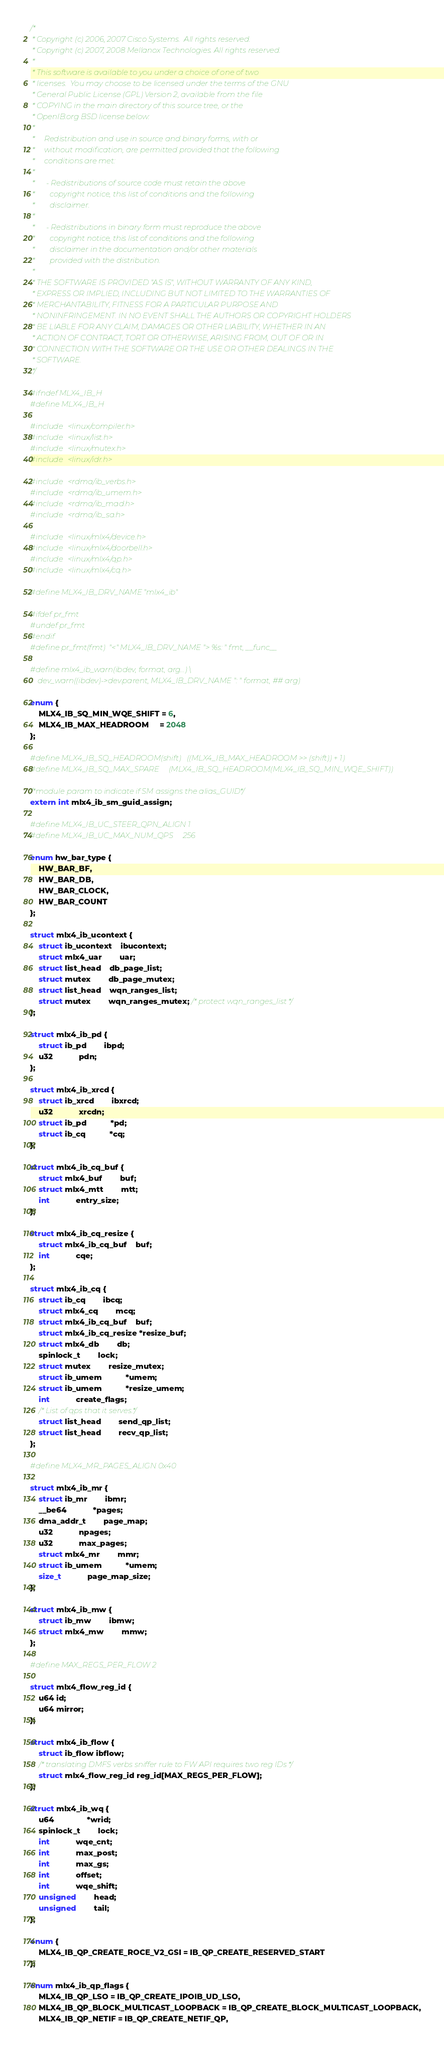Convert code to text. <code><loc_0><loc_0><loc_500><loc_500><_C_>/*
 * Copyright (c) 2006, 2007 Cisco Systems.  All rights reserved.
 * Copyright (c) 2007, 2008 Mellanox Technologies. All rights reserved.
 *
 * This software is available to you under a choice of one of two
 * licenses.  You may choose to be licensed under the terms of the GNU
 * General Public License (GPL) Version 2, available from the file
 * COPYING in the main directory of this source tree, or the
 * OpenIB.org BSD license below:
 *
 *     Redistribution and use in source and binary forms, with or
 *     without modification, are permitted provided that the following
 *     conditions are met:
 *
 *      - Redistributions of source code must retain the above
 *        copyright notice, this list of conditions and the following
 *        disclaimer.
 *
 *      - Redistributions in binary form must reproduce the above
 *        copyright notice, this list of conditions and the following
 *        disclaimer in the documentation and/or other materials
 *        provided with the distribution.
 *
 * THE SOFTWARE IS PROVIDED "AS IS", WITHOUT WARRANTY OF ANY KIND,
 * EXPRESS OR IMPLIED, INCLUDING BUT NOT LIMITED TO THE WARRANTIES OF
 * MERCHANTABILITY, FITNESS FOR A PARTICULAR PURPOSE AND
 * NONINFRINGEMENT. IN NO EVENT SHALL THE AUTHORS OR COPYRIGHT HOLDERS
 * BE LIABLE FOR ANY CLAIM, DAMAGES OR OTHER LIABILITY, WHETHER IN AN
 * ACTION OF CONTRACT, TORT OR OTHERWISE, ARISING FROM, OUT OF OR IN
 * CONNECTION WITH THE SOFTWARE OR THE USE OR OTHER DEALINGS IN THE
 * SOFTWARE.
 */

#ifndef MLX4_IB_H
#define MLX4_IB_H

#include <linux/compiler.h>
#include <linux/list.h>
#include <linux/mutex.h>
#include <linux/idr.h>

#include <rdma/ib_verbs.h>
#include <rdma/ib_umem.h>
#include <rdma/ib_mad.h>
#include <rdma/ib_sa.h>

#include <linux/mlx4/device.h>
#include <linux/mlx4/doorbell.h>
#include <linux/mlx4/qp.h>
#include <linux/mlx4/cq.h>

#define MLX4_IB_DRV_NAME	"mlx4_ib"

#ifdef pr_fmt
#undef pr_fmt
#endif
#define pr_fmt(fmt)	"<" MLX4_IB_DRV_NAME "> %s: " fmt, __func__

#define mlx4_ib_warn(ibdev, format, arg...) \
	dev_warn((ibdev)->dev.parent, MLX4_IB_DRV_NAME ": " format, ## arg)

enum {
	MLX4_IB_SQ_MIN_WQE_SHIFT = 6,
	MLX4_IB_MAX_HEADROOM	 = 2048
};

#define MLX4_IB_SQ_HEADROOM(shift)	((MLX4_IB_MAX_HEADROOM >> (shift)) + 1)
#define MLX4_IB_SQ_MAX_SPARE		(MLX4_IB_SQ_HEADROOM(MLX4_IB_SQ_MIN_WQE_SHIFT))

/*module param to indicate if SM assigns the alias_GUID*/
extern int mlx4_ib_sm_guid_assign;

#define MLX4_IB_UC_STEER_QPN_ALIGN 1
#define MLX4_IB_UC_MAX_NUM_QPS     256

enum hw_bar_type {
	HW_BAR_BF,
	HW_BAR_DB,
	HW_BAR_CLOCK,
	HW_BAR_COUNT
};

struct mlx4_ib_ucontext {
	struct ib_ucontext	ibucontext;
	struct mlx4_uar		uar;
	struct list_head	db_page_list;
	struct mutex		db_page_mutex;
	struct list_head	wqn_ranges_list;
	struct mutex		wqn_ranges_mutex; /* protect wqn_ranges_list */
};

struct mlx4_ib_pd {
	struct ib_pd		ibpd;
	u32			pdn;
};

struct mlx4_ib_xrcd {
	struct ib_xrcd		ibxrcd;
	u32			xrcdn;
	struct ib_pd	       *pd;
	struct ib_cq	       *cq;
};

struct mlx4_ib_cq_buf {
	struct mlx4_buf		buf;
	struct mlx4_mtt		mtt;
	int			entry_size;
};

struct mlx4_ib_cq_resize {
	struct mlx4_ib_cq_buf	buf;
	int			cqe;
};

struct mlx4_ib_cq {
	struct ib_cq		ibcq;
	struct mlx4_cq		mcq;
	struct mlx4_ib_cq_buf	buf;
	struct mlx4_ib_cq_resize *resize_buf;
	struct mlx4_db		db;
	spinlock_t		lock;
	struct mutex		resize_mutex;
	struct ib_umem	       *umem;
	struct ib_umem	       *resize_umem;
	int			create_flags;
	/* List of qps that it serves.*/
	struct list_head		send_qp_list;
	struct list_head		recv_qp_list;
};

#define MLX4_MR_PAGES_ALIGN 0x40

struct mlx4_ib_mr {
	struct ib_mr		ibmr;
	__be64			*pages;
	dma_addr_t		page_map;
	u32			npages;
	u32			max_pages;
	struct mlx4_mr		mmr;
	struct ib_umem	       *umem;
	size_t			page_map_size;
};

struct mlx4_ib_mw {
	struct ib_mw		ibmw;
	struct mlx4_mw		mmw;
};

#define MAX_REGS_PER_FLOW 2

struct mlx4_flow_reg_id {
	u64 id;
	u64 mirror;
};

struct mlx4_ib_flow {
	struct ib_flow ibflow;
	/* translating DMFS verbs sniffer rule to FW API requires two reg IDs */
	struct mlx4_flow_reg_id reg_id[MAX_REGS_PER_FLOW];
};

struct mlx4_ib_wq {
	u64		       *wrid;
	spinlock_t		lock;
	int			wqe_cnt;
	int			max_post;
	int			max_gs;
	int			offset;
	int			wqe_shift;
	unsigned		head;
	unsigned		tail;
};

enum {
	MLX4_IB_QP_CREATE_ROCE_V2_GSI = IB_QP_CREATE_RESERVED_START
};

enum mlx4_ib_qp_flags {
	MLX4_IB_QP_LSO = IB_QP_CREATE_IPOIB_UD_LSO,
	MLX4_IB_QP_BLOCK_MULTICAST_LOOPBACK = IB_QP_CREATE_BLOCK_MULTICAST_LOOPBACK,
	MLX4_IB_QP_NETIF = IB_QP_CREATE_NETIF_QP,</code> 